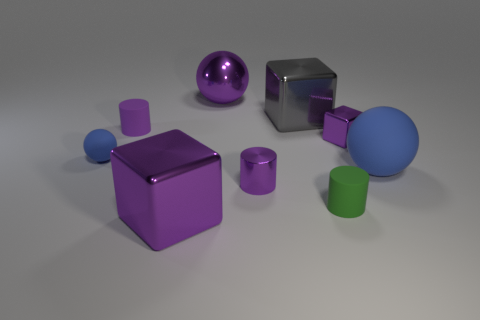How many objects in this image share the same color as the largest cube? From this image, there are three objects that share a similar shade of purple with the largest cube. There's a smaller cube, a sphere, and a tube-like object, all in varying shades of purple, suggesting a theme in their color scheme. 